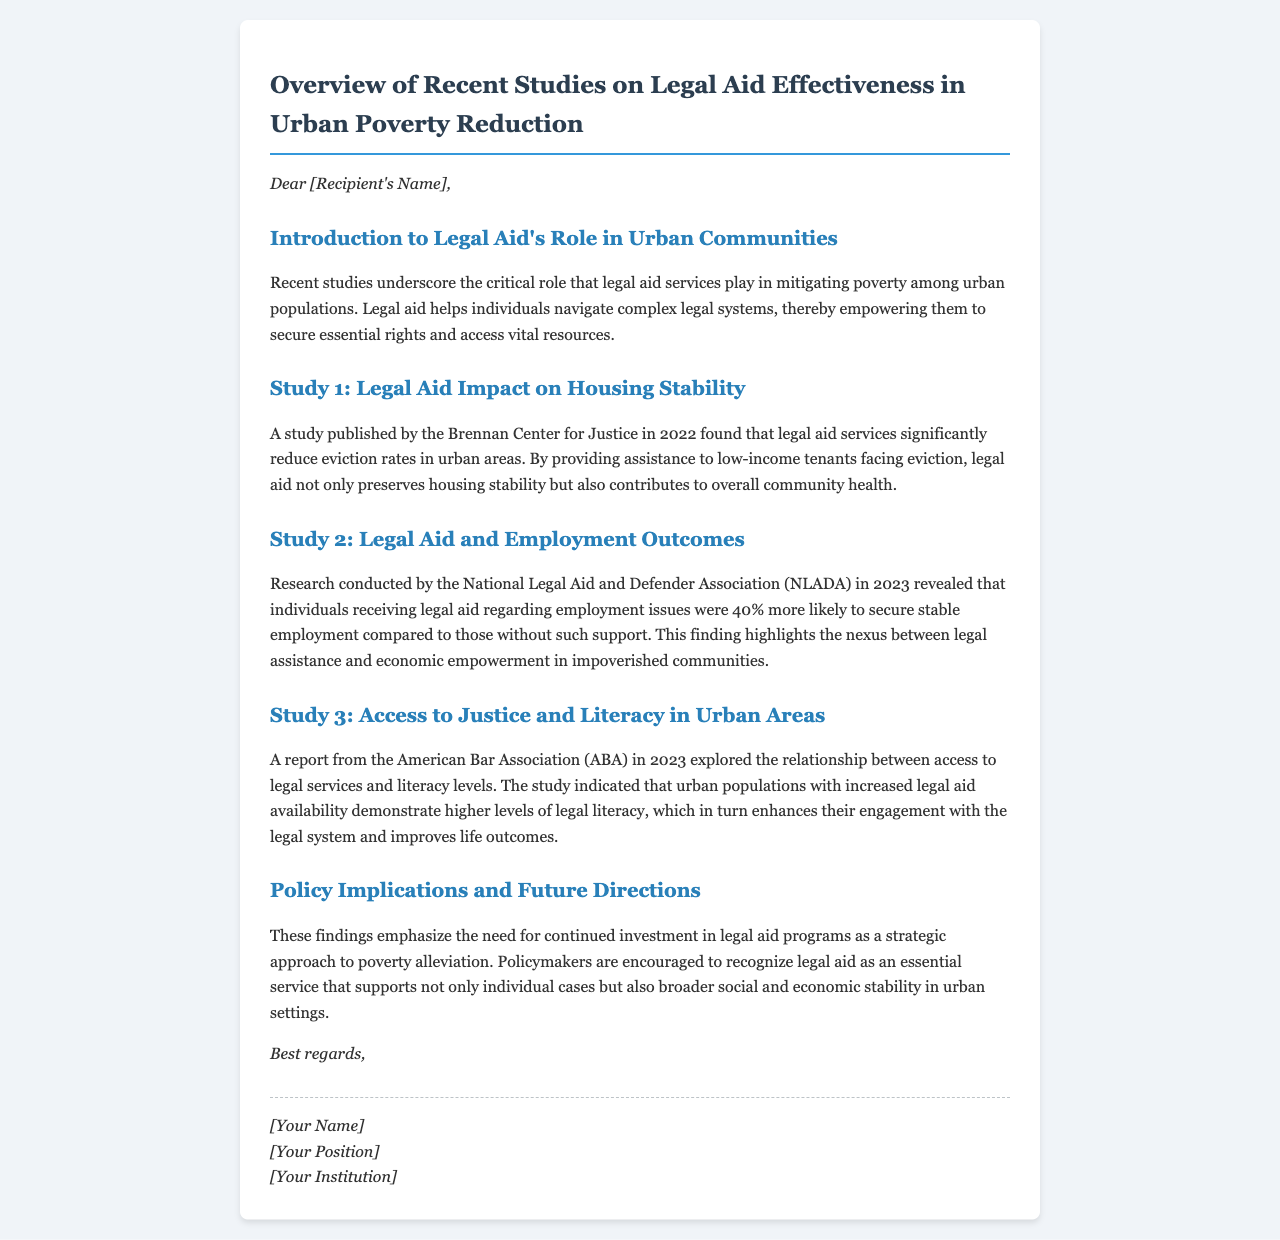What is the title of the document? The title of the document is provided in the header section, stating the focus on legal aid effectiveness.
Answer: Overview of Recent Studies on Legal Aid Effectiveness in Urban Poverty Reduction Who published the study on housing stability? The document mentions the Brennan Center for Justice as the publisher of the study regarding housing stability.
Answer: Brennan Center for Justice What percentage increase in stable employment was noted for individuals receiving legal aid for employment issues? The research states that individuals receiving legal aid were 40% more likely to secure stable employment compared to others.
Answer: 40% In what year was the research on employment outcomes conducted? The document specifies that the research conducted by the National Legal Aid and Defender Association occurred in 2023.
Answer: 2023 Which organization conducted the study on access to justice and literacy? The study that explored the relationship between access to legal services and literacy levels was conducted by the American Bar Association.
Answer: American Bar Association What key role does legal aid play in urban communities according to recent studies? The core role described in the document is helping individuals navigate complex legal systems, empowering them for resource access.
Answer: Empowerment to secure essential rights What do policymakers need to recognize according to the policy implications? The document suggests policymakers should acknowledge legal aid as an essential service for broader social and economic stability.
Answer: Essential service What year was the study on housing stability published? The document specifies that the study on housing stability was published in 2022.
Answer: 2022 What is the main benefit of legal aid services mentioned in the introduction? The introduction highlights that legal aid services help mitigate poverty among urban populations.
Answer: Mitigating poverty 